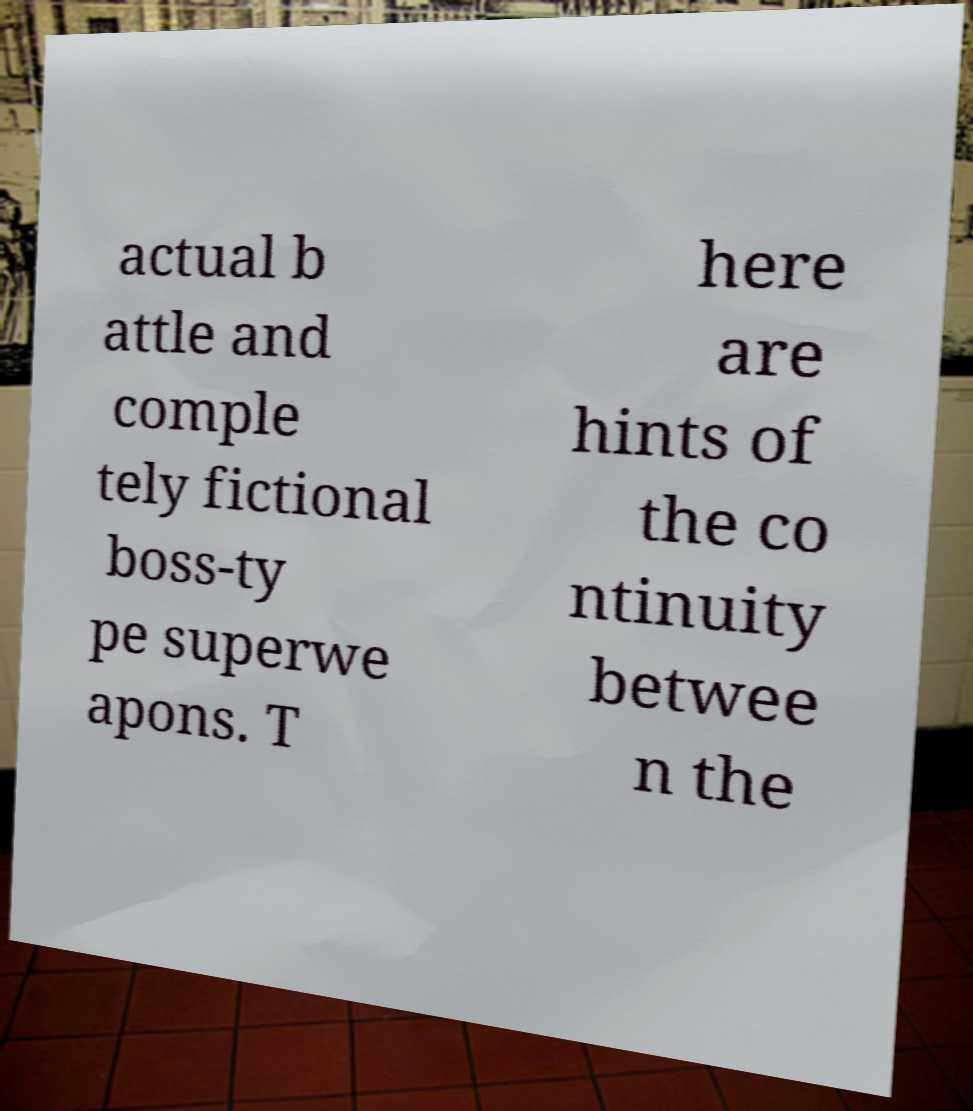For documentation purposes, I need the text within this image transcribed. Could you provide that? actual b attle and comple tely fictional boss-ty pe superwe apons. T here are hints of the co ntinuity betwee n the 